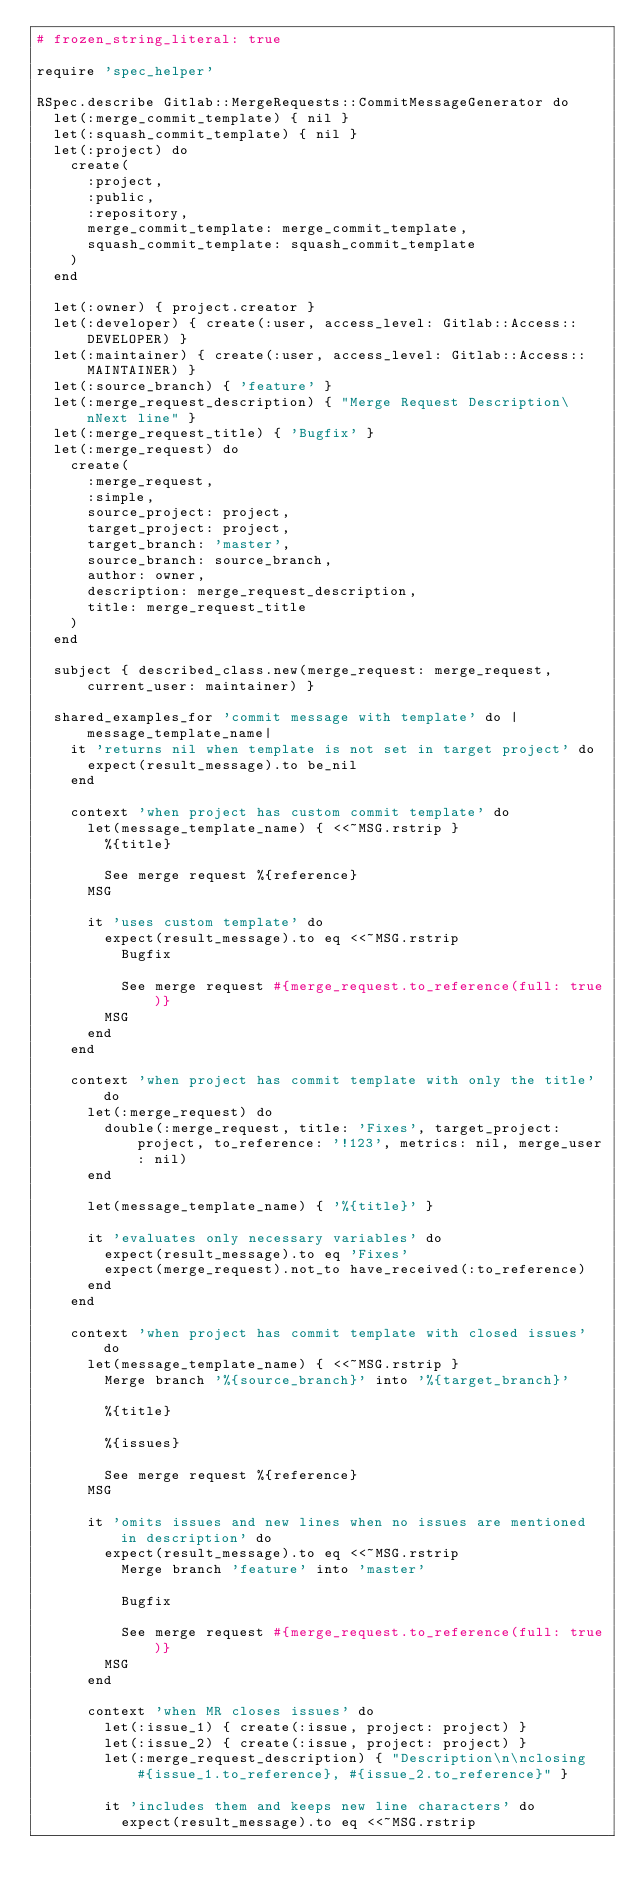<code> <loc_0><loc_0><loc_500><loc_500><_Ruby_># frozen_string_literal: true

require 'spec_helper'

RSpec.describe Gitlab::MergeRequests::CommitMessageGenerator do
  let(:merge_commit_template) { nil }
  let(:squash_commit_template) { nil }
  let(:project) do
    create(
      :project,
      :public,
      :repository,
      merge_commit_template: merge_commit_template,
      squash_commit_template: squash_commit_template
    )
  end

  let(:owner) { project.creator }
  let(:developer) { create(:user, access_level: Gitlab::Access::DEVELOPER) }
  let(:maintainer) { create(:user, access_level: Gitlab::Access::MAINTAINER) }
  let(:source_branch) { 'feature' }
  let(:merge_request_description) { "Merge Request Description\nNext line" }
  let(:merge_request_title) { 'Bugfix' }
  let(:merge_request) do
    create(
      :merge_request,
      :simple,
      source_project: project,
      target_project: project,
      target_branch: 'master',
      source_branch: source_branch,
      author: owner,
      description: merge_request_description,
      title: merge_request_title
    )
  end

  subject { described_class.new(merge_request: merge_request, current_user: maintainer) }

  shared_examples_for 'commit message with template' do |message_template_name|
    it 'returns nil when template is not set in target project' do
      expect(result_message).to be_nil
    end

    context 'when project has custom commit template' do
      let(message_template_name) { <<~MSG.rstrip }
        %{title}

        See merge request %{reference}
      MSG

      it 'uses custom template' do
        expect(result_message).to eq <<~MSG.rstrip
          Bugfix

          See merge request #{merge_request.to_reference(full: true)}
        MSG
      end
    end

    context 'when project has commit template with only the title' do
      let(:merge_request) do
        double(:merge_request, title: 'Fixes', target_project: project, to_reference: '!123', metrics: nil, merge_user: nil)
      end

      let(message_template_name) { '%{title}' }

      it 'evaluates only necessary variables' do
        expect(result_message).to eq 'Fixes'
        expect(merge_request).not_to have_received(:to_reference)
      end
    end

    context 'when project has commit template with closed issues' do
      let(message_template_name) { <<~MSG.rstrip }
        Merge branch '%{source_branch}' into '%{target_branch}'

        %{title}

        %{issues}

        See merge request %{reference}
      MSG

      it 'omits issues and new lines when no issues are mentioned in description' do
        expect(result_message).to eq <<~MSG.rstrip
          Merge branch 'feature' into 'master'

          Bugfix

          See merge request #{merge_request.to_reference(full: true)}
        MSG
      end

      context 'when MR closes issues' do
        let(:issue_1) { create(:issue, project: project) }
        let(:issue_2) { create(:issue, project: project) }
        let(:merge_request_description) { "Description\n\nclosing #{issue_1.to_reference}, #{issue_2.to_reference}" }

        it 'includes them and keeps new line characters' do
          expect(result_message).to eq <<~MSG.rstrip</code> 